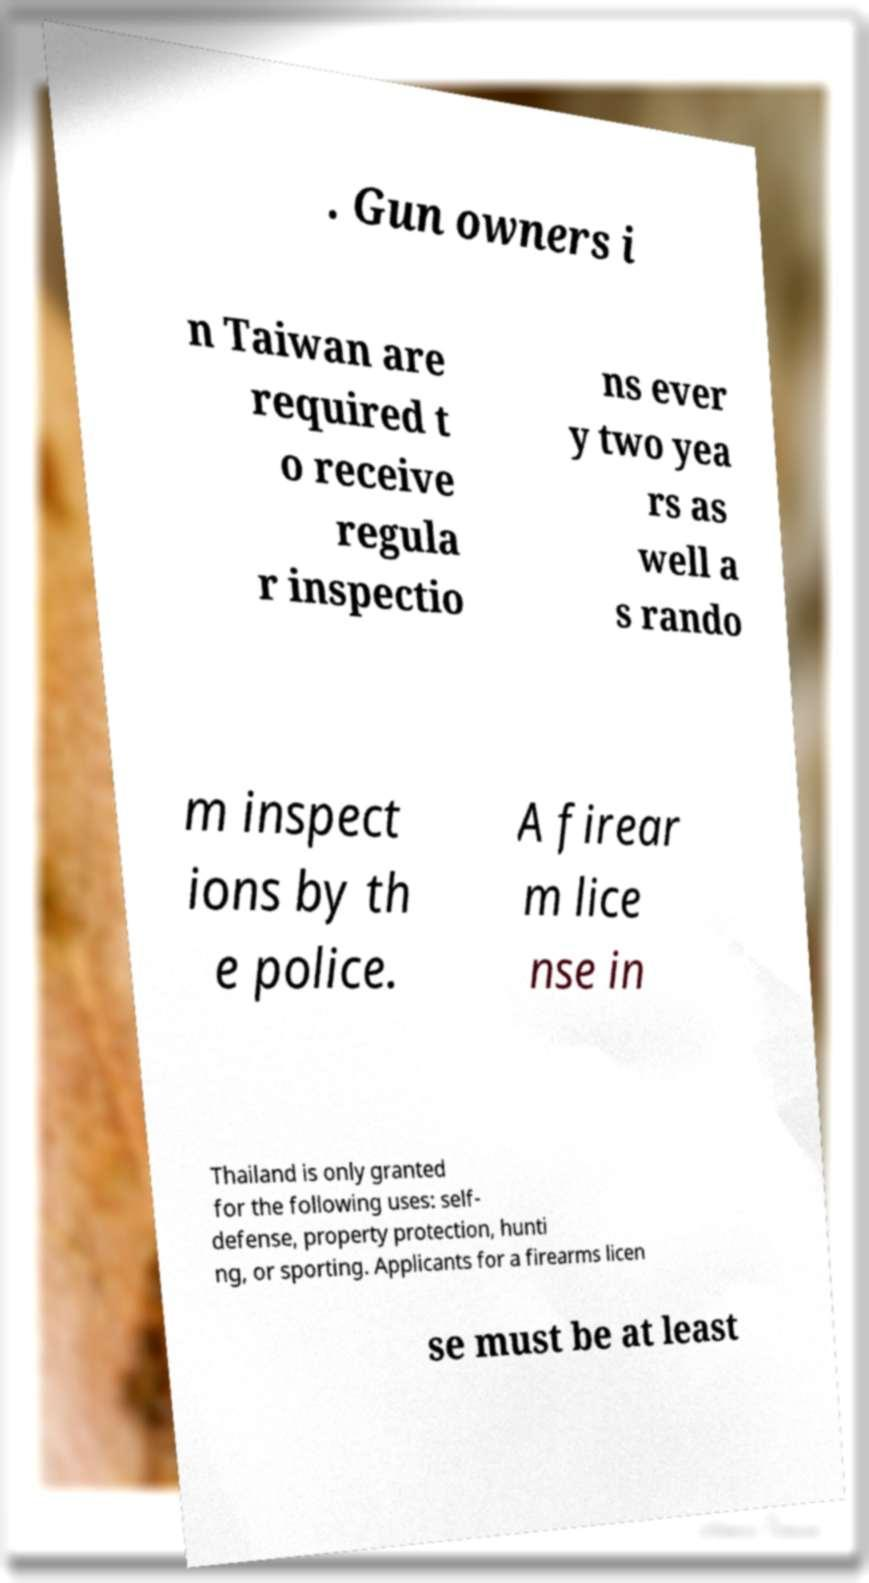For documentation purposes, I need the text within this image transcribed. Could you provide that? . Gun owners i n Taiwan are required t o receive regula r inspectio ns ever y two yea rs as well a s rando m inspect ions by th e police. A firear m lice nse in Thailand is only granted for the following uses: self- defense, property protection, hunti ng, or sporting. Applicants for a firearms licen se must be at least 